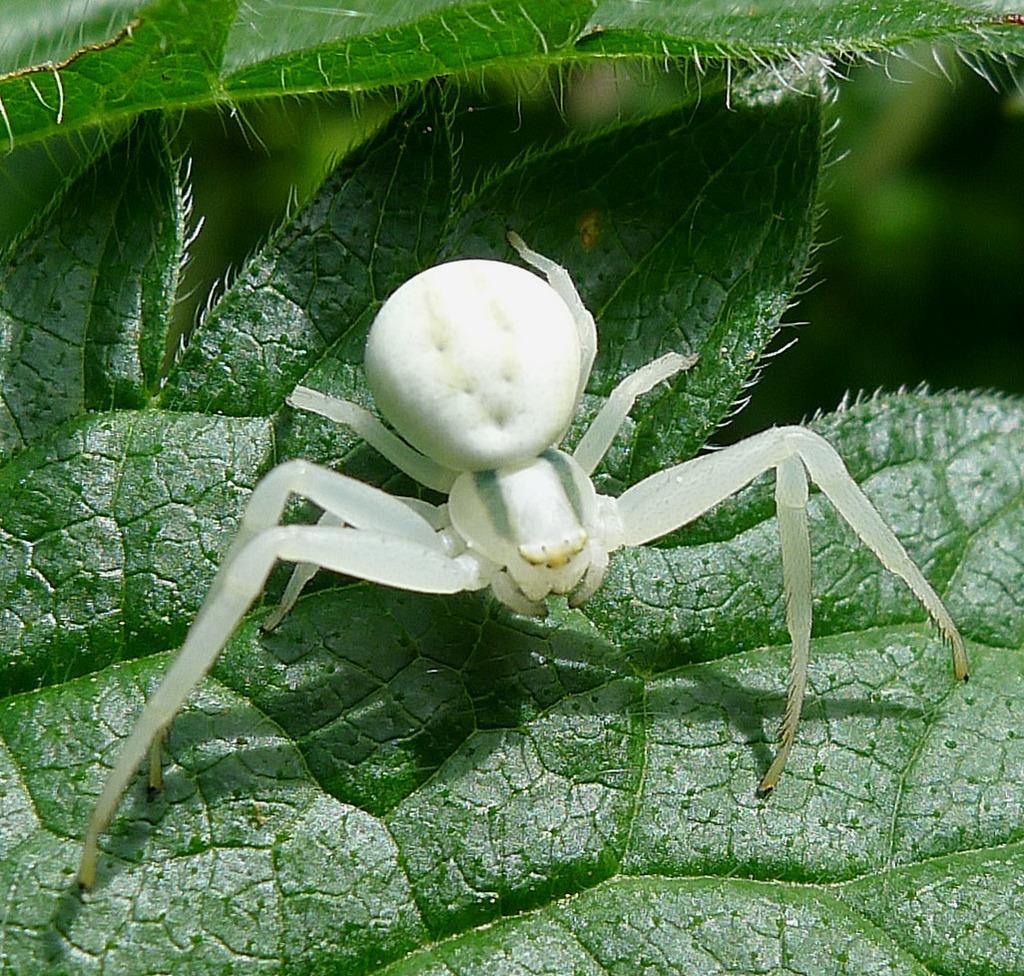What is the main subject of the image? There is a spider in the image. Where is the spider located? The spider is on a leaf. What else can be seen in the image besides the spider? There are leaves visible in the background of the image. What health advice can be given to the babies in the image? There are no babies present in the image, so no health advice can be given. 